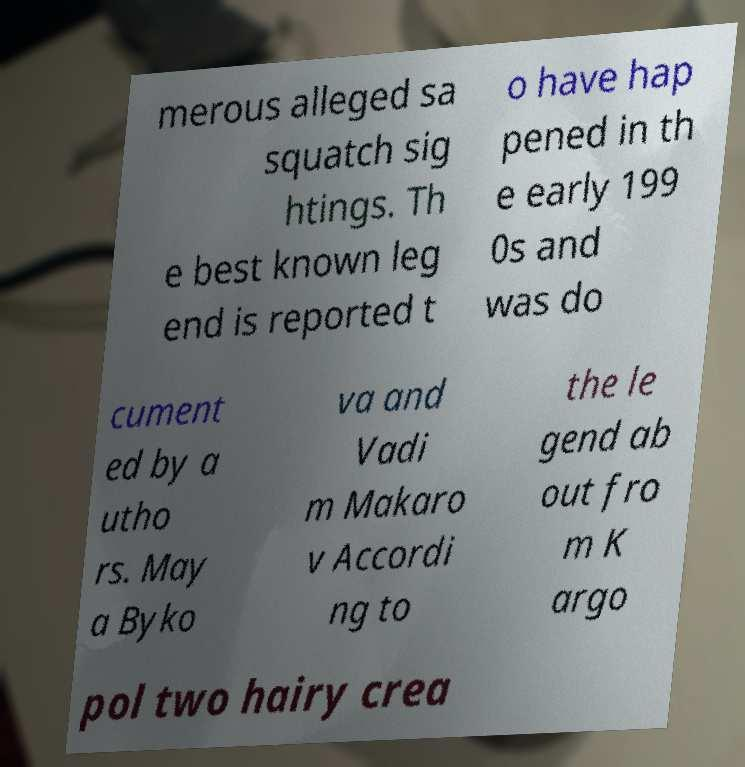Please read and relay the text visible in this image. What does it say? merous alleged sa squatch sig htings. Th e best known leg end is reported t o have hap pened in th e early 199 0s and was do cument ed by a utho rs. May a Byko va and Vadi m Makaro v Accordi ng to the le gend ab out fro m K argo pol two hairy crea 